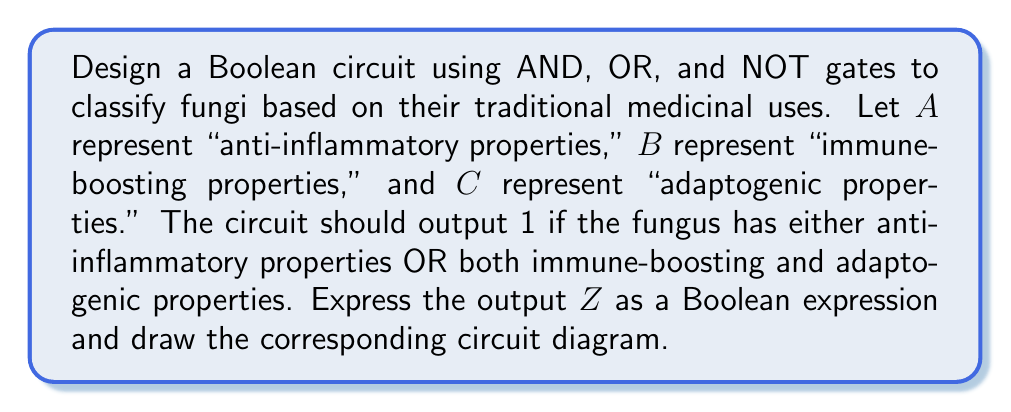Can you answer this question? To solve this problem, we'll follow these steps:

1. Translate the classification criteria into a Boolean expression:
   The output Z should be 1 if:
   - The fungus has anti-inflammatory properties (A), OR
   - The fungus has both immune-boosting (B) AND adaptogenic (C) properties

2. Write the Boolean expression:
   $$Z = A + (B \cdot C)$$
   Where "+" represents OR, and "·" represents AND

3. Simplify the expression (if possible):
   In this case, the expression is already in its simplest form.

4. Design the circuit:
   - Use an AND gate for (B · C)
   - Use an OR gate to combine A with the result of (B · C)

5. Draw the circuit diagram:

[asy]
import geometry;

pair A = (0,80), B = (0,40), C = (0,0);
pair AND = (80,20), OR = (160,50);
pair Z = (240,50);

draw(A--OR);
draw(B--AND);
draw(C--AND);
draw(AND--OR);
draw(OR--Z);

label("A", A, W);
label("B", B, W);
label("C", C, W);
label("Z", Z, E);

draw(circle(AND,20));
label("&", AND);

draw(circle(OR,20));
label("≥1", OR);

[/asy]

This circuit represents the Boolean expression $$Z = A + (B \cdot C)$$, which correctly classifies fungi based on the given criteria.
Answer: $$Z = A + (B \cdot C)$$ 